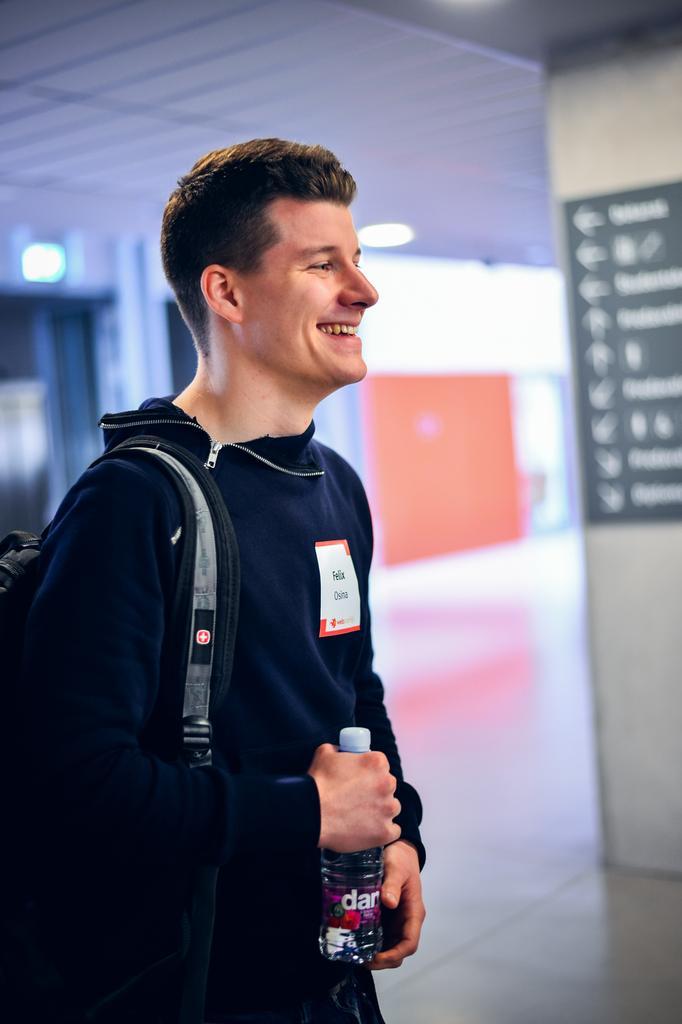Describe this image in one or two sentences. In this image, we can see a man is wearing a backpack and holding a bottle. He is smiling. Background there is a blur view. Here we can see floor, wall, poster, lights. 